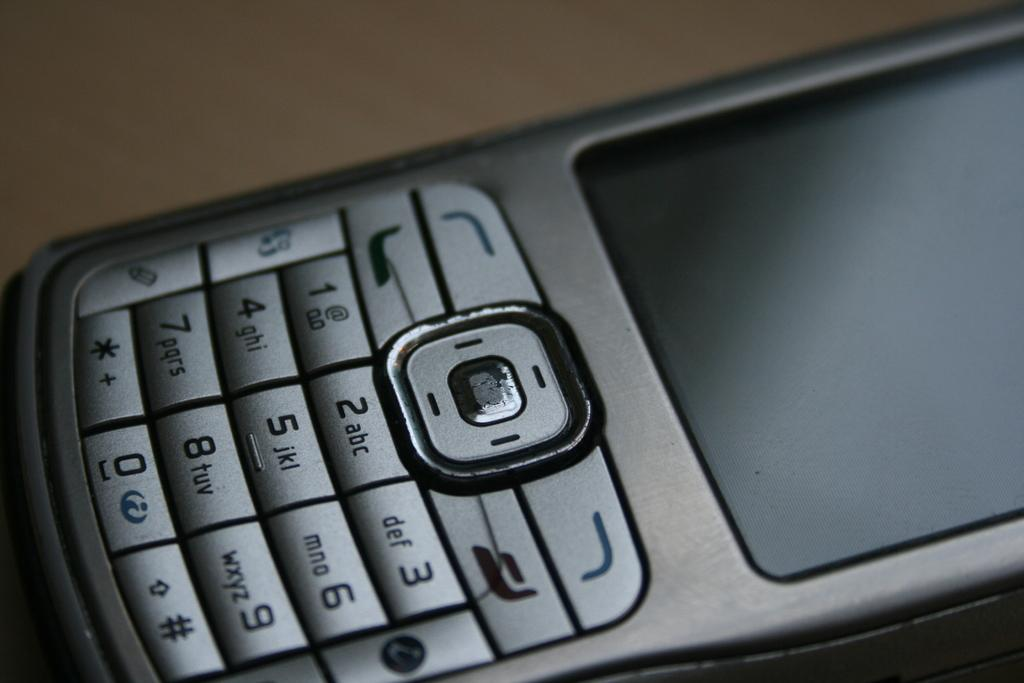<image>
Create a compact narrative representing the image presented. a phone that has the number 3 on it 